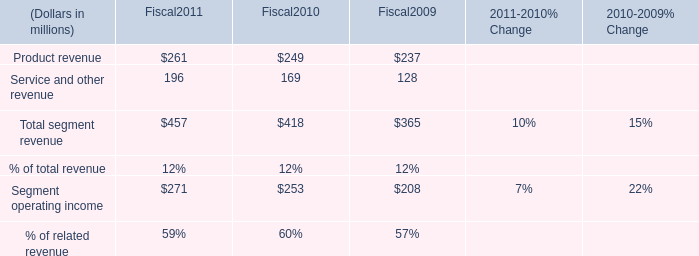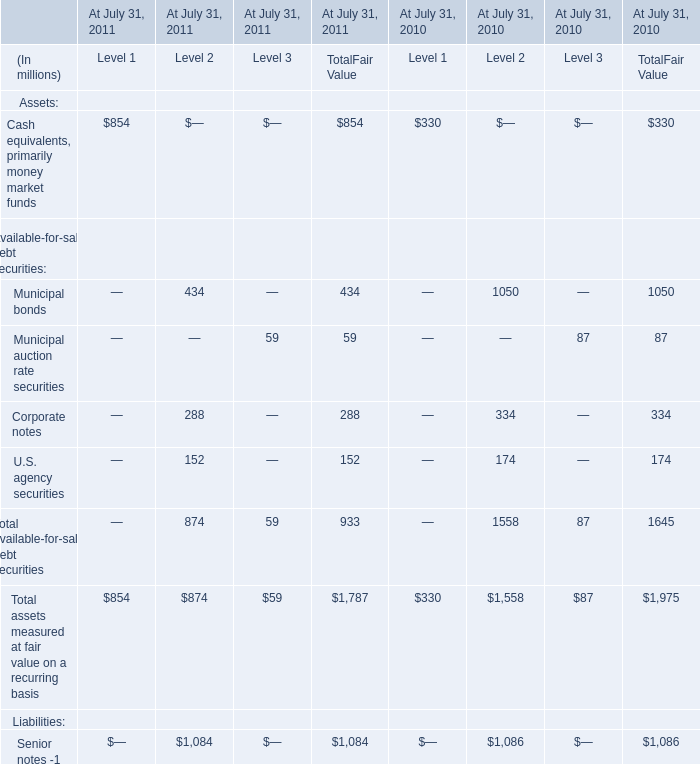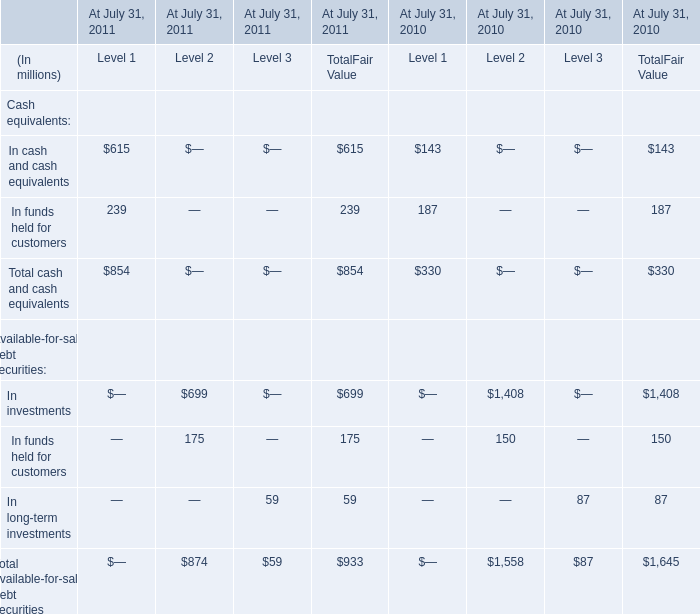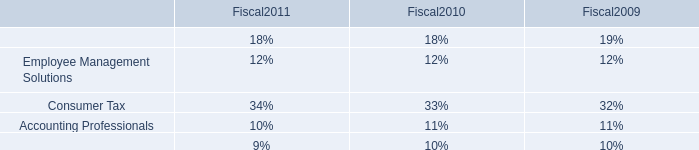Which year is Cash equivalents, primarily money market funds for TotalFair Value the most? 
Answer: 2011. 